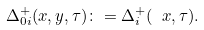<formula> <loc_0><loc_0><loc_500><loc_500>\Delta _ { 0 i } ^ { + } ( x , y , \tau ) \colon = { \Delta } _ { i } ^ { + } ( \ x , \tau ) .</formula> 